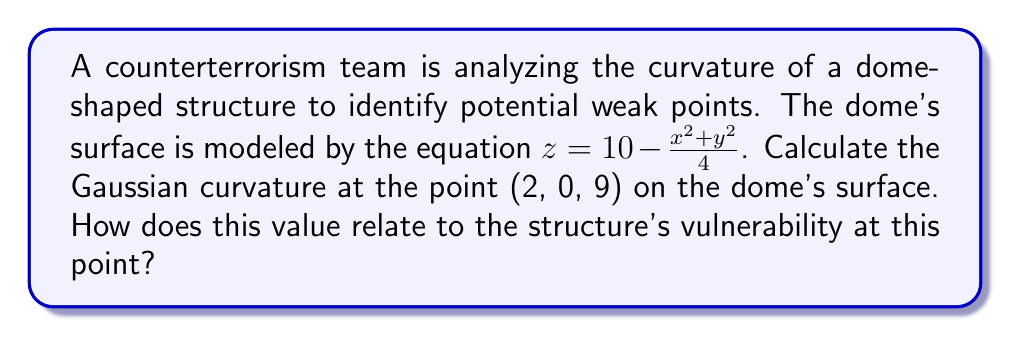Solve this math problem. To analyze the curvature and assess potential weak points, we need to calculate the Gaussian curvature of the surface at the given point. Let's proceed step-by-step:

1) The surface is given by $z = f(x,y) = 10 - \frac{x^2 + y^2}{4}$

2) To find the Gaussian curvature, we need to calculate the following partial derivatives:

   $f_x = -\frac{x}{2}$
   $f_y = -\frac{y}{2}$
   $f_{xx} = -\frac{1}{2}$
   $f_{yy} = -\frac{1}{2}$
   $f_{xy} = 0$

3) The Gaussian curvature K is given by the formula:

   $$K = \frac{f_{xx}f_{yy} - f_{xy}^2}{(1 + f_x^2 + f_y^2)^2}$$

4) At the point (2, 0, 9):

   $f_x = -1$
   $f_y = 0$
   $f_{xx} = -\frac{1}{2}$
   $f_{yy} = -\frac{1}{2}$
   $f_{xy} = 0$

5) Substituting these values into the formula:

   $$K = \frac{(-\frac{1}{2})(-\frac{1}{2}) - 0^2}{(1 + (-1)^2 + 0^2)^2} = \frac{1/4}{4} = \frac{1}{16} = 0.0625$$

6) The Gaussian curvature at (2, 0, 9) is positive, indicating that the surface is elliptic at this point. In terms of structural integrity, positive curvature generally implies better strength and resistance to deformation compared to areas with zero or negative curvature.

7) However, the relatively low value (0.0625) suggests that while the point is not a weak spot, it's not the strongest point of the structure either. The highest curvature (and potentially strongest point) would be at the dome's apex.
Answer: $K = \frac{1}{16} = 0.0625$; moderate strength, not a critical weak point. 